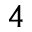<formula> <loc_0><loc_0><loc_500><loc_500>^ { 4 }</formula> 